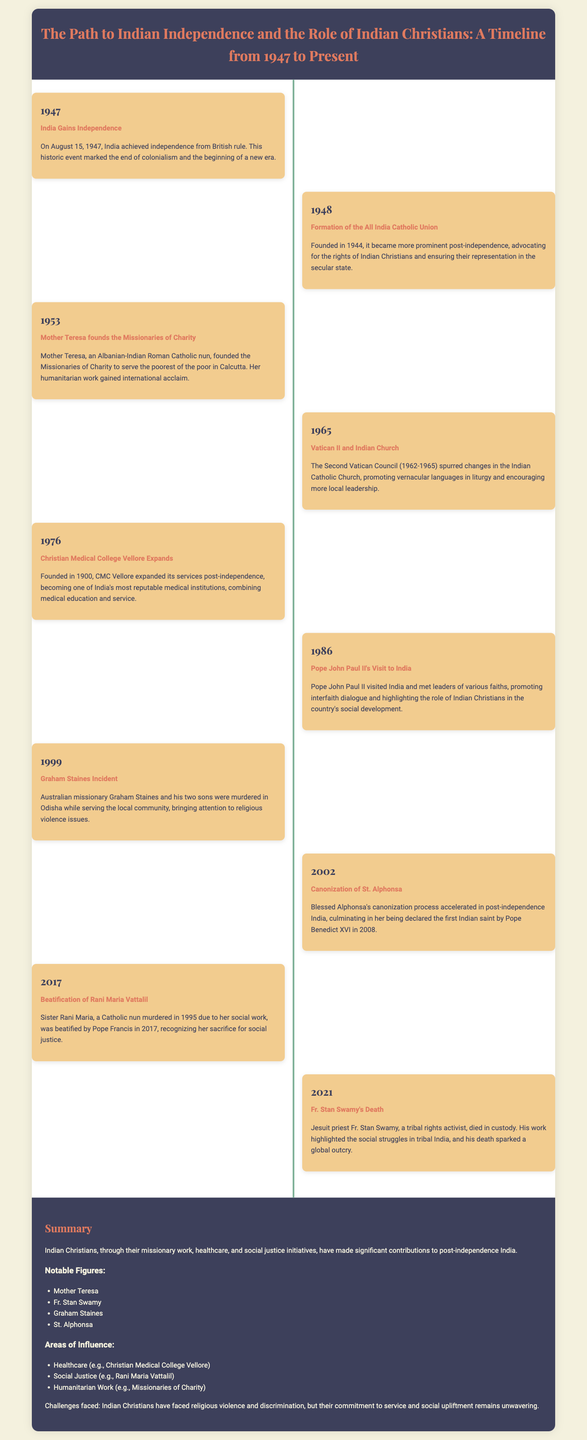What year did India gain independence? The document states that India gained independence on August 15, 1947.
Answer: 1947 Who founded the Missionaries of Charity? According to the document, Mother Teresa founded the Missionaries of Charity in 1953.
Answer: Mother Teresa What significant event occurred in 1986 related to the Pope? The document mentions that Pope John Paul II visited India in 1986.
Answer: Pope John Paul II's Visit Which Indian saint was canonized in 2008? The document states that Blessed Alphonsa was canonized in 2008, making her the first Indian saint.
Answer: St. Alphonsa What area of influence is highlighted by the Christian Medical College Vellore? The document describes that CMC Vellore contributed to the area of healthcare in India.
Answer: Healthcare What tragic event involving Graham Staines occurred in 1999? The document notes that Graham Staines and his sons were murdered in Odisha in 1999.
Answer: Graham Staines Incident What does the summary emphasize about the contributions of Indian Christians? The summary highlights that Indian Christians made significant contributions to post-independence India through service and social upliftment.
Answer: Significant contributions What decade did Vatican II influence changes in the Indian Catholic Church? The document indicates that Vatican II spurred changes in the Indian Catholic Church during the 1960s.
Answer: 1960s 